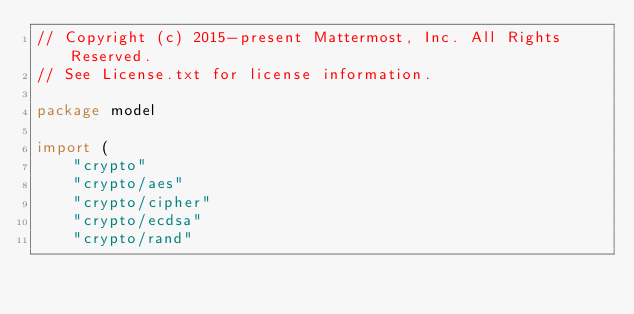Convert code to text. <code><loc_0><loc_0><loc_500><loc_500><_Go_>// Copyright (c) 2015-present Mattermost, Inc. All Rights Reserved.
// See License.txt for license information.

package model

import (
	"crypto"
	"crypto/aes"
	"crypto/cipher"
	"crypto/ecdsa"
	"crypto/rand"</code> 